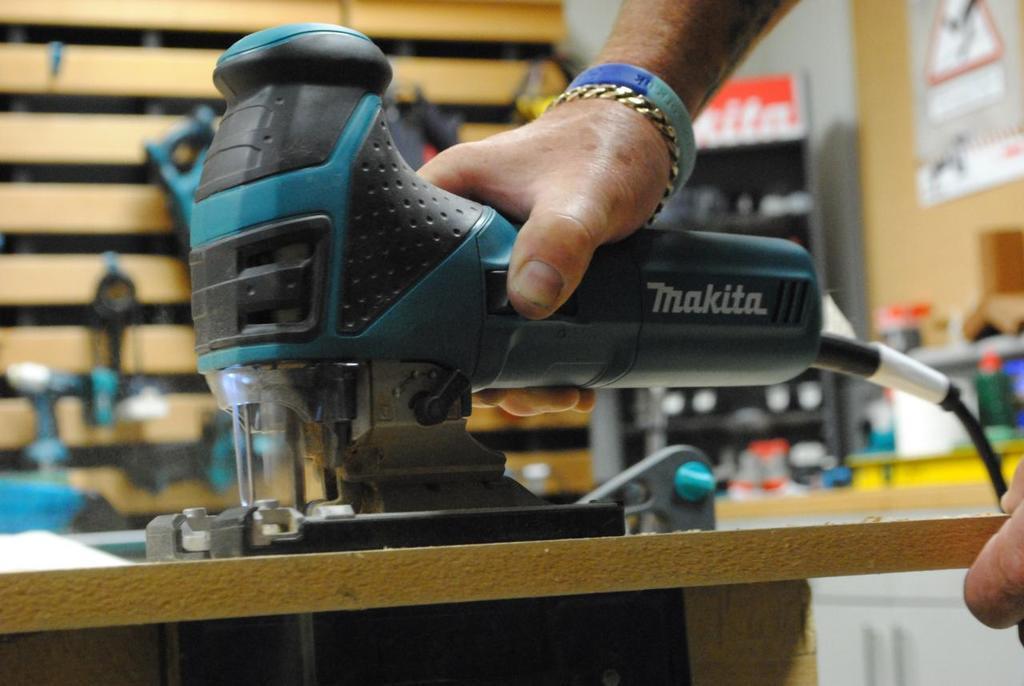Can you describe this image briefly? In the image we can see there is a man holding drilling machine in his hand and behind there are other equipments kept on the wall. Background of the image is little blurred 